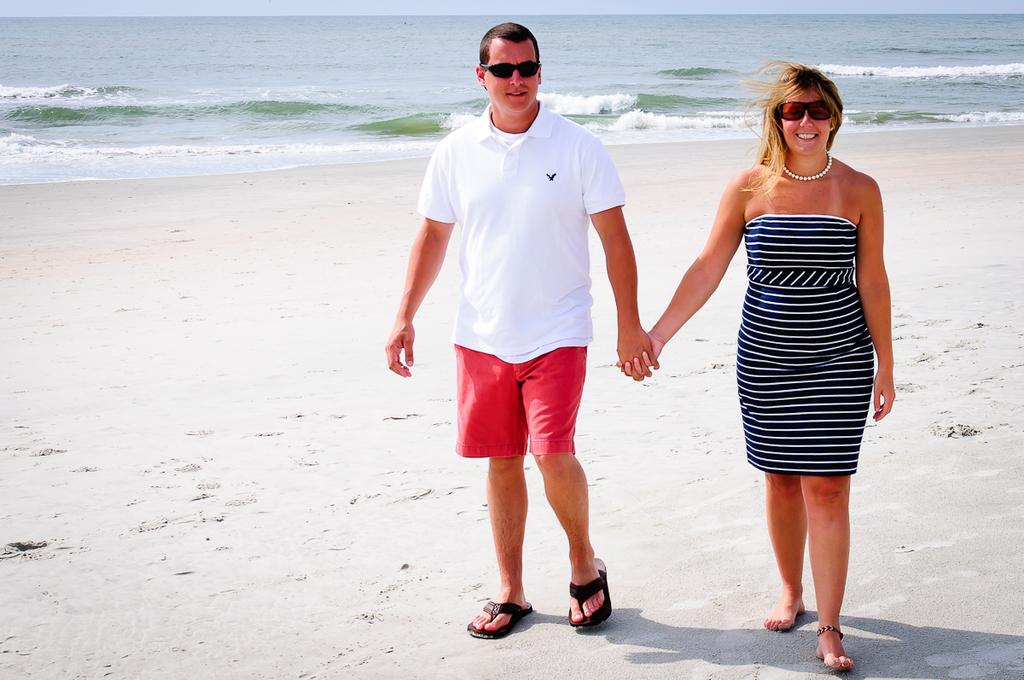How many people are present in the image? There are two people, a man and a woman, present in the image. What are the man and woman wearing on their faces? Both the man and woman are wearing goggles. What type of terrain are the man and woman walking on? The man and woman are walking on sand. What is the emotional state of the man and woman in the image? The man and woman are smiling in the image. What can be seen in the background of the image? There is water and the sky visible in the background of the image. What type of vein is visible on the man's forehead in the image? There is no visible vein on the man's forehead in the image. How many slaves are present in the image? There are no slaves present in the image; it features a man and a woman walking on sand. 